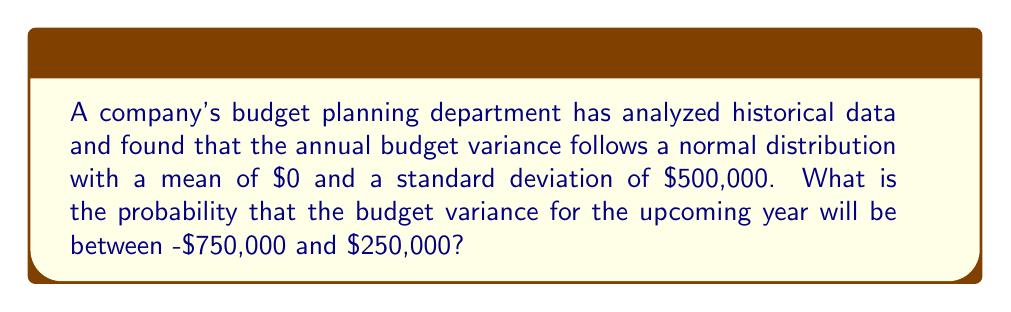Solve this math problem. To solve this problem, we need to use the properties of the normal distribution and the concept of z-scores.

Given:
- The budget variance follows a normal distribution
- Mean ($\mu$) = $0
- Standard deviation ($\sigma$) = $500,000

Step 1: Calculate the z-scores for the given bounds.

Lower bound: $z_1 = \frac{x_1 - \mu}{\sigma} = \frac{-750,000 - 0}{500,000} = -1.5$
Upper bound: $z_2 = \frac{x_2 - \mu}{\sigma} = \frac{250,000 - 0}{500,000} = 0.5$

Step 2: Use the standard normal distribution table or a calculator to find the area between these z-scores.

The probability is equal to the area under the standard normal curve between $z_1$ and $z_2$.

$P(-1.5 < Z < 0.5) = P(Z < 0.5) - P(Z < -1.5)$

Using a standard normal table or calculator:
$P(Z < 0.5) = 0.6915$
$P(Z < -1.5) = 0.0668$

Step 3: Calculate the final probability.

$P(-1.5 < Z < 0.5) = 0.6915 - 0.0668 = 0.6247$

Therefore, the probability that the budget variance will be between -$750,000 and $250,000 is approximately 0.6247 or 62.47%.
Answer: The probability that the budget variance for the upcoming year will be between -$750,000 and $250,000 is approximately 0.6247 or 62.47%. 